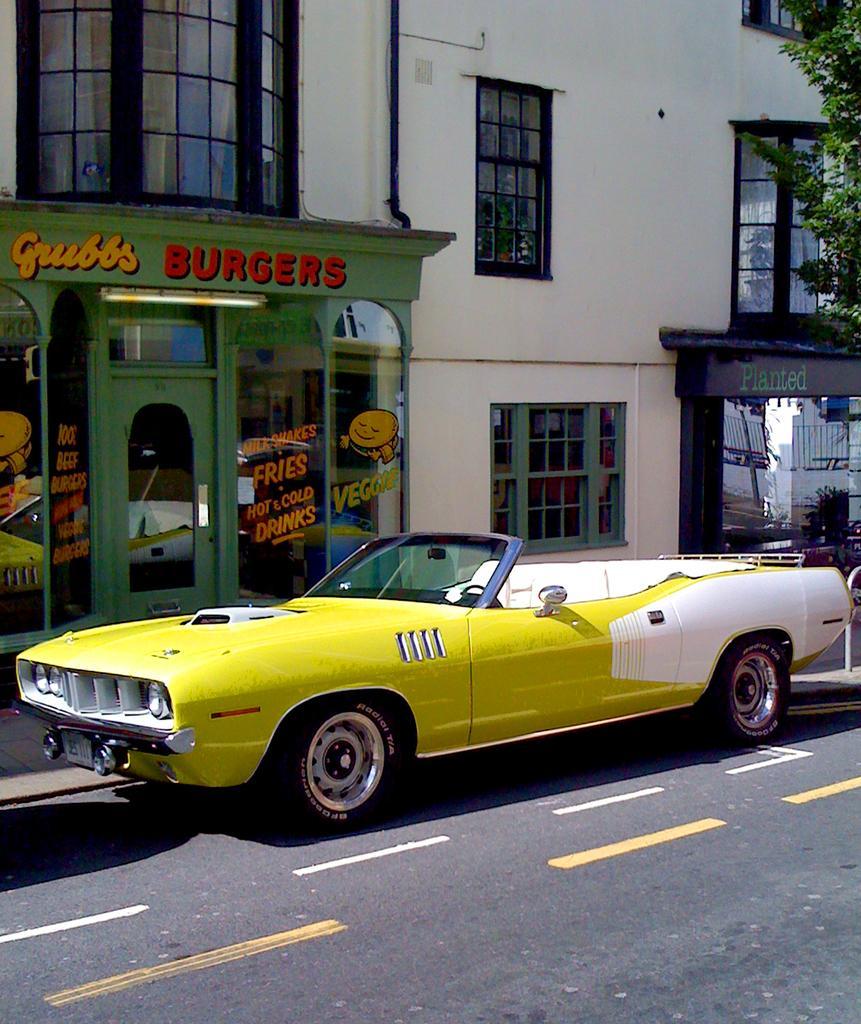Can you describe this image briefly? In this image, we can see a car in front of the building. There is a branch in the top right of the image. 